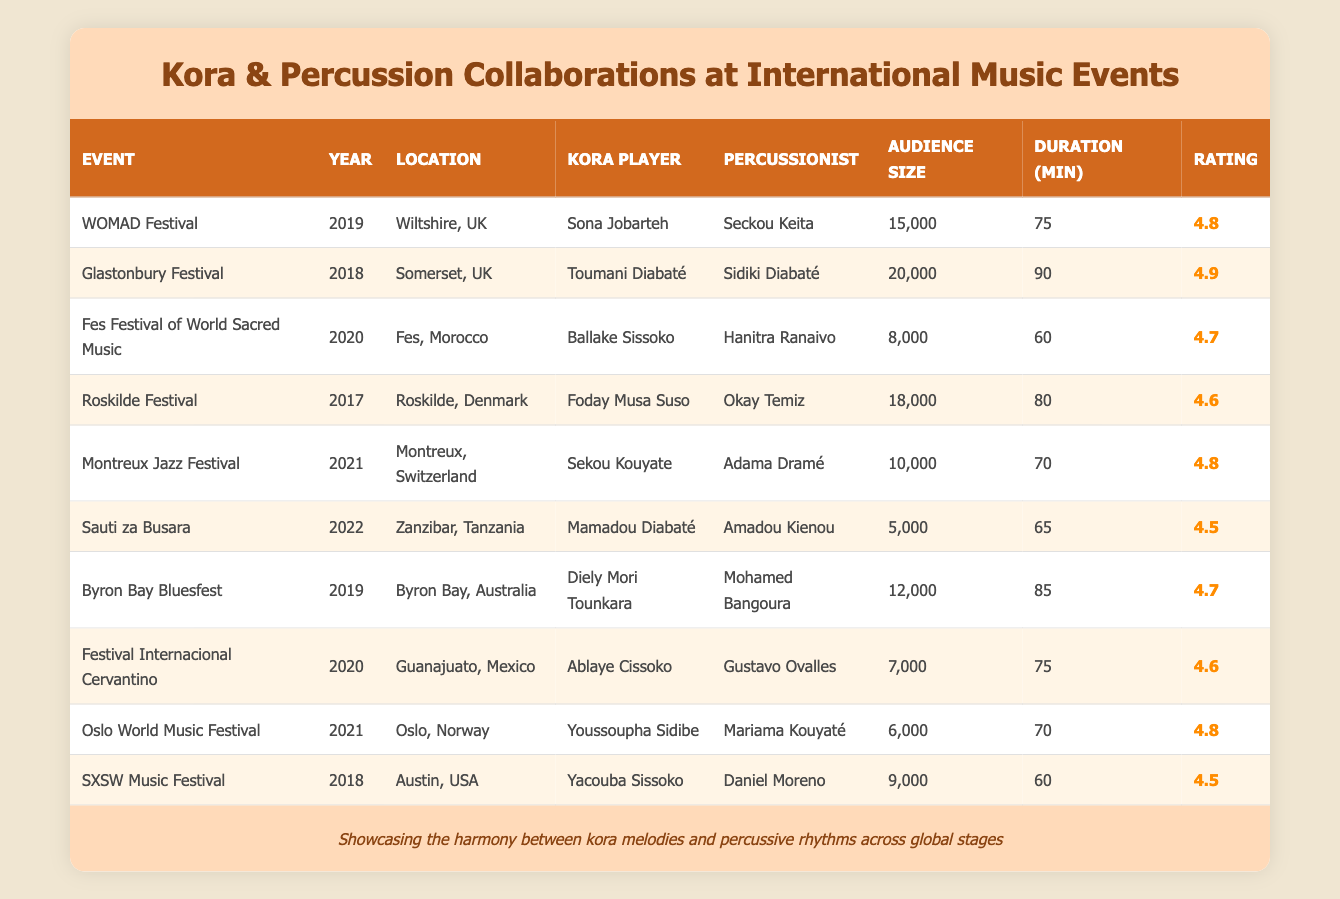What is the highest audience size recorded in the table? By examining the audience size column, the largest value is found in the row corresponding to the Glastonbury Festival in 2018 with an audience size of 20,000.
Answer: 20,000 Which performance lasted the longest? The longest duration is found in the Glastonbury Festival entry for 2018, where the performance lasted 90 minutes.
Answer: 90 How many performances took place in 2021? There are two entries for the year 2021: the Montreux Jazz Festival and the Oslo World Music Festival.
Answer: 2 Which kora player performed with the highest-rated percussionist? The performance with the highest rating is at the Glastonbury Festival in 2018 where Toumani Diabaté performed with Sidiki Diabaté rated at 4.9.
Answer: Toumani Diabaté What is the average audience size across all performances? Summing the audience sizes (15,000 + 20,000 + 8,000 + 18,000 + 10,000 + 5,000 + 12,000 + 7,000 + 6,000 + 9,000) gives 110,000. Dividing by the number of performances (10), the average audience size is 11,000.
Answer: 11,000 Did any performance have an audience size below 10,000? Yes, the performances at the Fes Festival of World Sacred Music (8,000), Sauti za Busara (5,000), and the Festival Internacional Cervantino (7,000) all had audience sizes below 10,000.
Answer: Yes What is the median duration of the performances? Listing the durations in order (60, 60, 65, 70, 70, 75, 75, 80, 85, 90), the median values are the 5th and 6th entries (75 and 75), thus, the median is 75.
Answer: 75 Was every kora player featured in performances rated above 4.5? Not all kora players had ratings above 4.5; the performance at Sauti za Busara in 2022 was rated at 4.5, indicating that this rating does not exceed 4.5.
Answer: No Which location hosted the performance with the lowest audience size? The performance at Sauti za Busara in Zanzibar, Tanzania, had the lowest audience size at 5,000, making it the lowest on the list.
Answer: Zanzibar, Tanzania Which event featured multiple prominent kora players? The Glastonbury Festival in 2018 featured Toumani Diabaté, one of the most renowned kora players, alongside Sidiki Diabaté, another notable artist in the same field.
Answer: Glastonbury Festival 